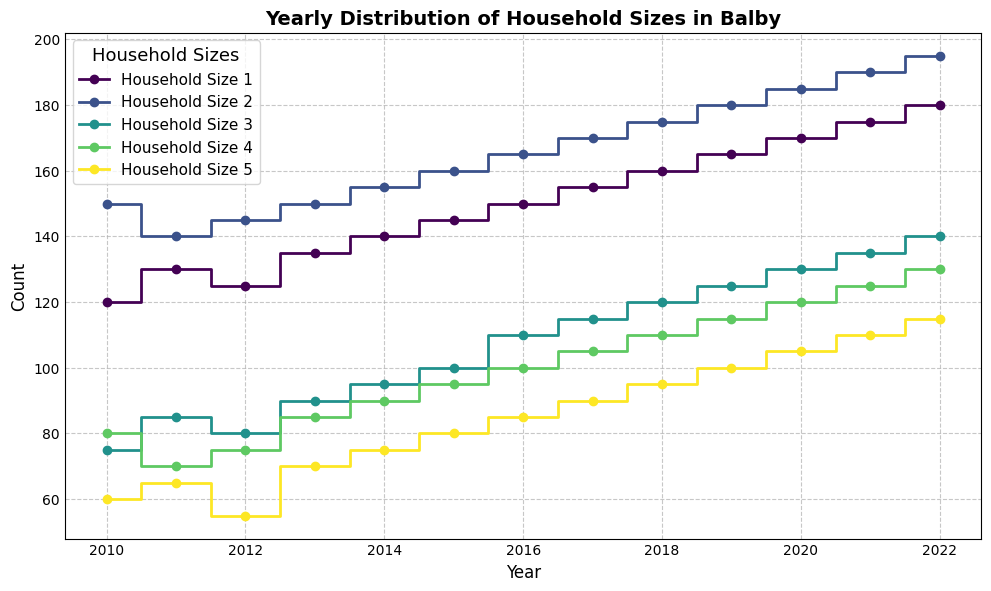What is the trend of households with 1 person from 2010 to 2022? To determine the trend, look at the progression of the counts for household size 1 from 2010 to 2022. The count for household size 1 shows a steady increase from 120 in 2010 to 180 in 2022. Hence, the trend is an upward one.
Answer: Upward trend Which household size had the highest count in 2015? By checking the data points on the figure for the year 2015, we can see that household size 2 had the highest count with a value of 160.
Answer: 2 How did the count for household size 3 change from 2016 to 2020? Look at the step plot lines for household size 3 between 2016 and 2020. In 2016, the count is 110 and increases each year to 130 by 2020. This shows a consistent increase.
Answer: Increased In which year did household size 5 have the smallest count? Observing the figure, we can see the values of household size 5 across the years. The smallest value appears in 2012 with a count of 55.
Answer: 2012 What is the average count for household size 4 over all the years displayed? Sum the counts for household size 4 across all years and divide by the number of years (13). (80+70+75+85+90+95+100+105+110+115+120+125+130)/13 = 1025/13 ≈ 78.8
Answer: 78.8 Which household size had the steadiest growth rate from 2010 to 2022? Steady growth implies a near-linear increase. By visually inspecting the step plots, household size 2 shows a consistent growth each year from 150 in 2010 to 195 in 2022.
Answer: 2 What is the difference in counts for household size 5 between 2010 and 2022? To find the difference, subtract the count for 2010 (60) from the count for 2022 (115). 115 - 60 = 55
Answer: 55 In what year did household size 1 surpass 150 for the first time? From the figure, check the plot points for household size 1 and find where it first exceeds 150—this happens in the year 2016.
Answer: 2016 How much total did household size 4 increase from 2010 to 2022? Subtract the 2010 value (80) from the 2022 value (130), which gives an increase of 130 - 80 = 50.
Answer: 50 Which household size saw the largest increase in count from 2010 to 2022? Calculating the increase for each household size:
1: 180 - 120 = 60
2: 195 - 150 = 45
3: 140 - 75 = 65
4: 130 - 80 = 50
5: 115 - 60 = 55
Household size 3 saw the largest increase.
Answer: 3 